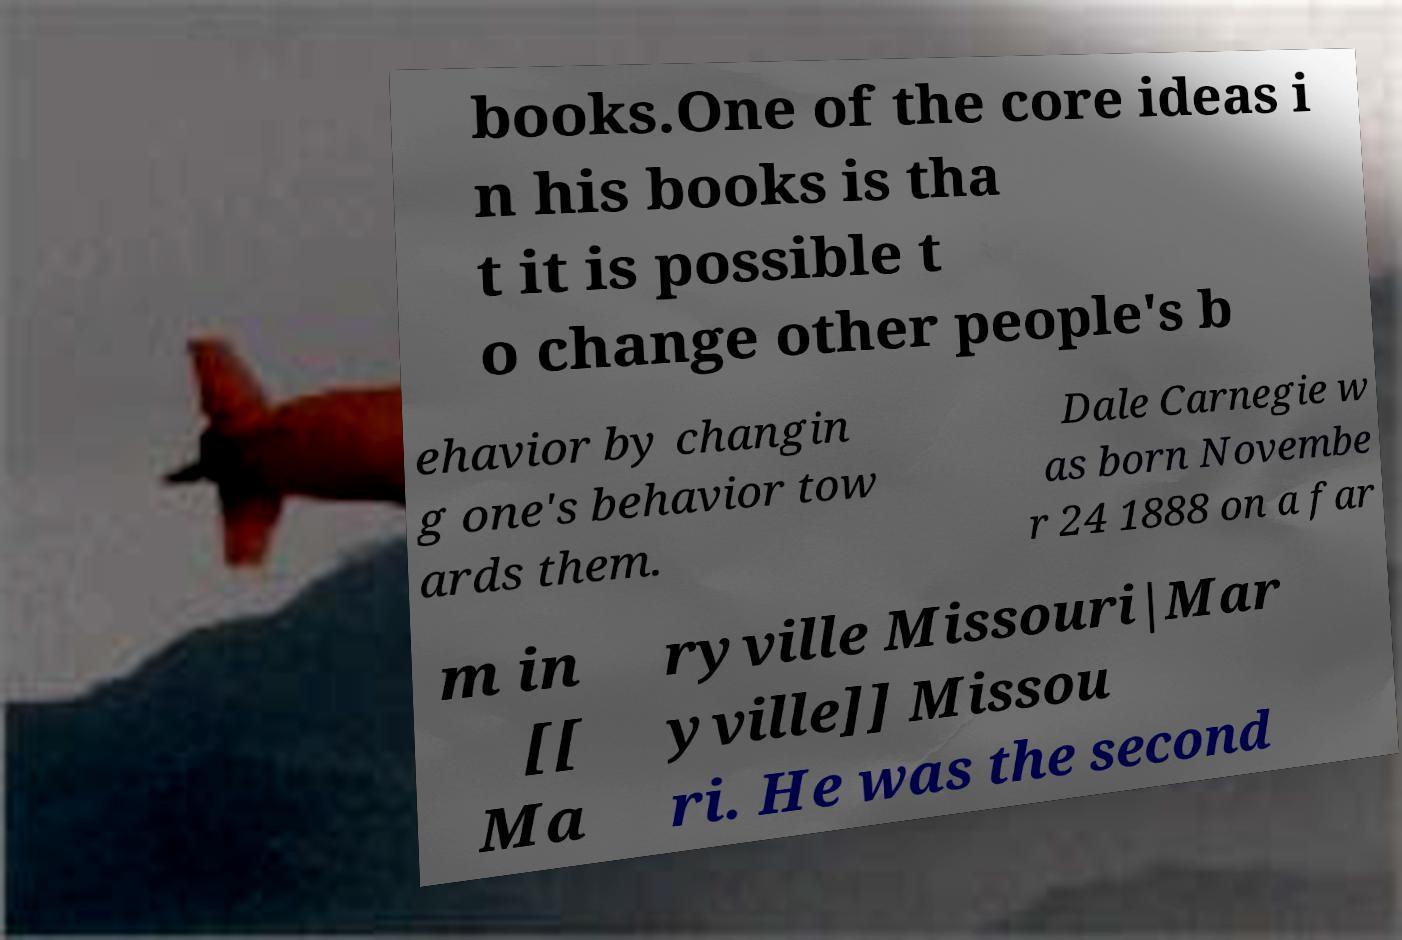Please identify and transcribe the text found in this image. books.One of the core ideas i n his books is tha t it is possible t o change other people's b ehavior by changin g one's behavior tow ards them. Dale Carnegie w as born Novembe r 24 1888 on a far m in [[ Ma ryville Missouri|Mar yville]] Missou ri. He was the second 